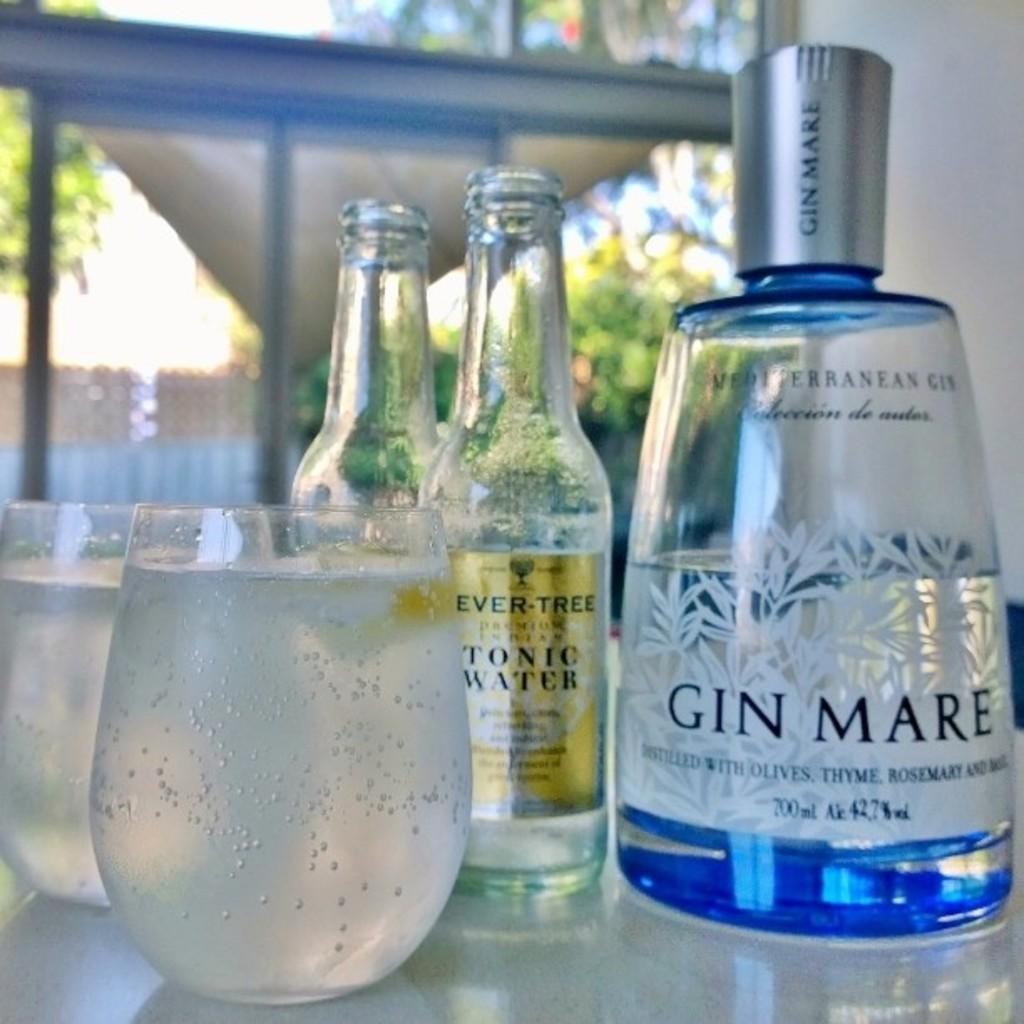Please provide a concise description of this image. This picture is of inside. In the foreground there is a table on the top of which three glass bottles and two glasses containing drinks are placed. In the background there is a tent, sky, trees and a wall. 